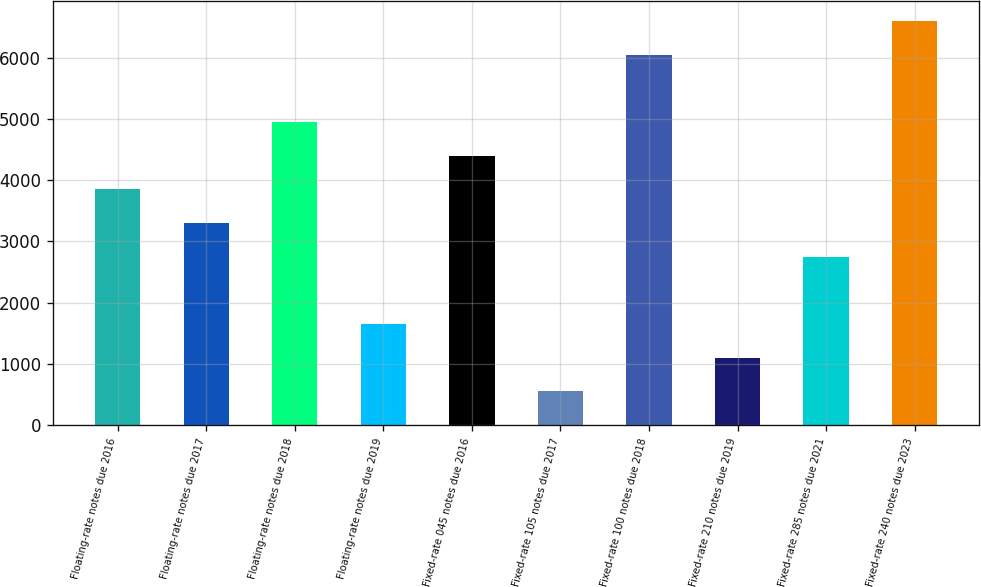Convert chart to OTSL. <chart><loc_0><loc_0><loc_500><loc_500><bar_chart><fcel>Floating-rate notes due 2016<fcel>Floating-rate notes due 2017<fcel>Floating-rate notes due 2018<fcel>Floating-rate notes due 2019<fcel>Fixed-rate 045 notes due 2016<fcel>Fixed-rate 105 notes due 2017<fcel>Fixed-rate 100 notes due 2018<fcel>Fixed-rate 210 notes due 2019<fcel>Fixed-rate 285 notes due 2021<fcel>Fixed-rate 240 notes due 2023<nl><fcel>3850.64<fcel>3300.84<fcel>4950.24<fcel>1651.44<fcel>4400.44<fcel>551.84<fcel>6049.84<fcel>1101.64<fcel>2751.04<fcel>6599.64<nl></chart> 